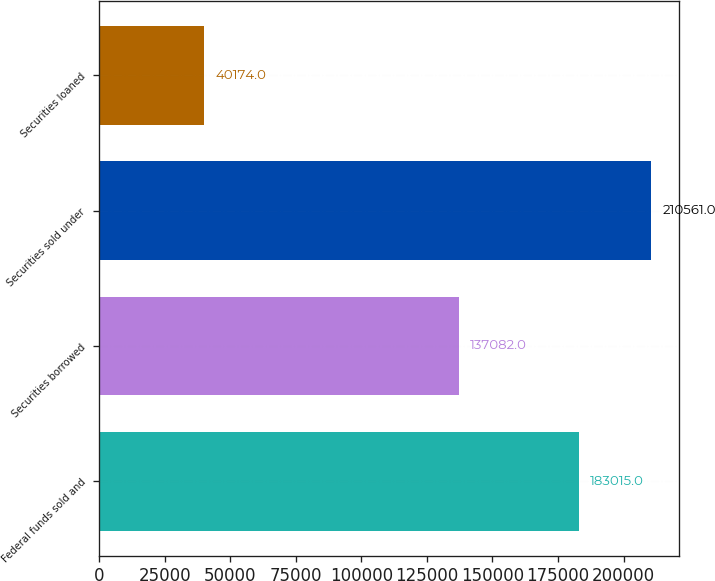<chart> <loc_0><loc_0><loc_500><loc_500><bar_chart><fcel>Federal funds sold and<fcel>Securities borrowed<fcel>Securities sold under<fcel>Securities loaned<nl><fcel>183015<fcel>137082<fcel>210561<fcel>40174<nl></chart> 